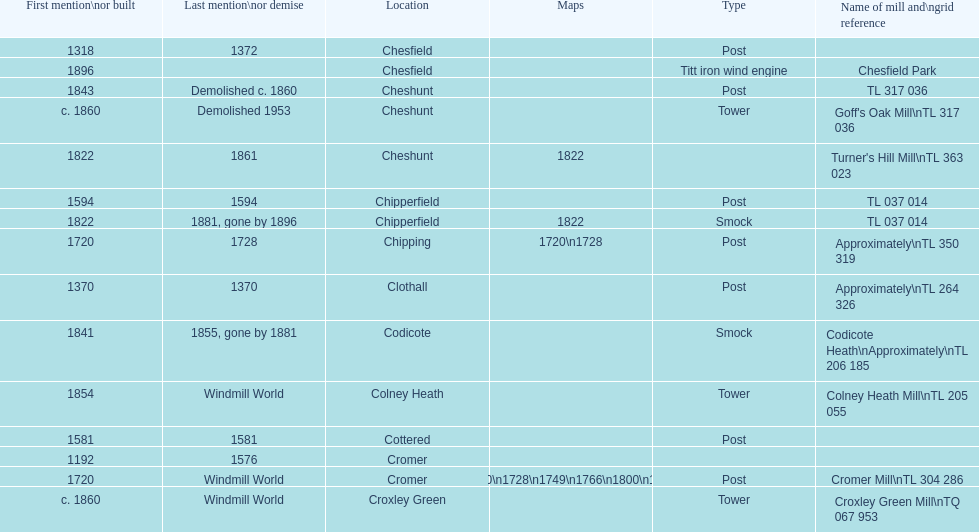What location has the most maps? Cromer. 